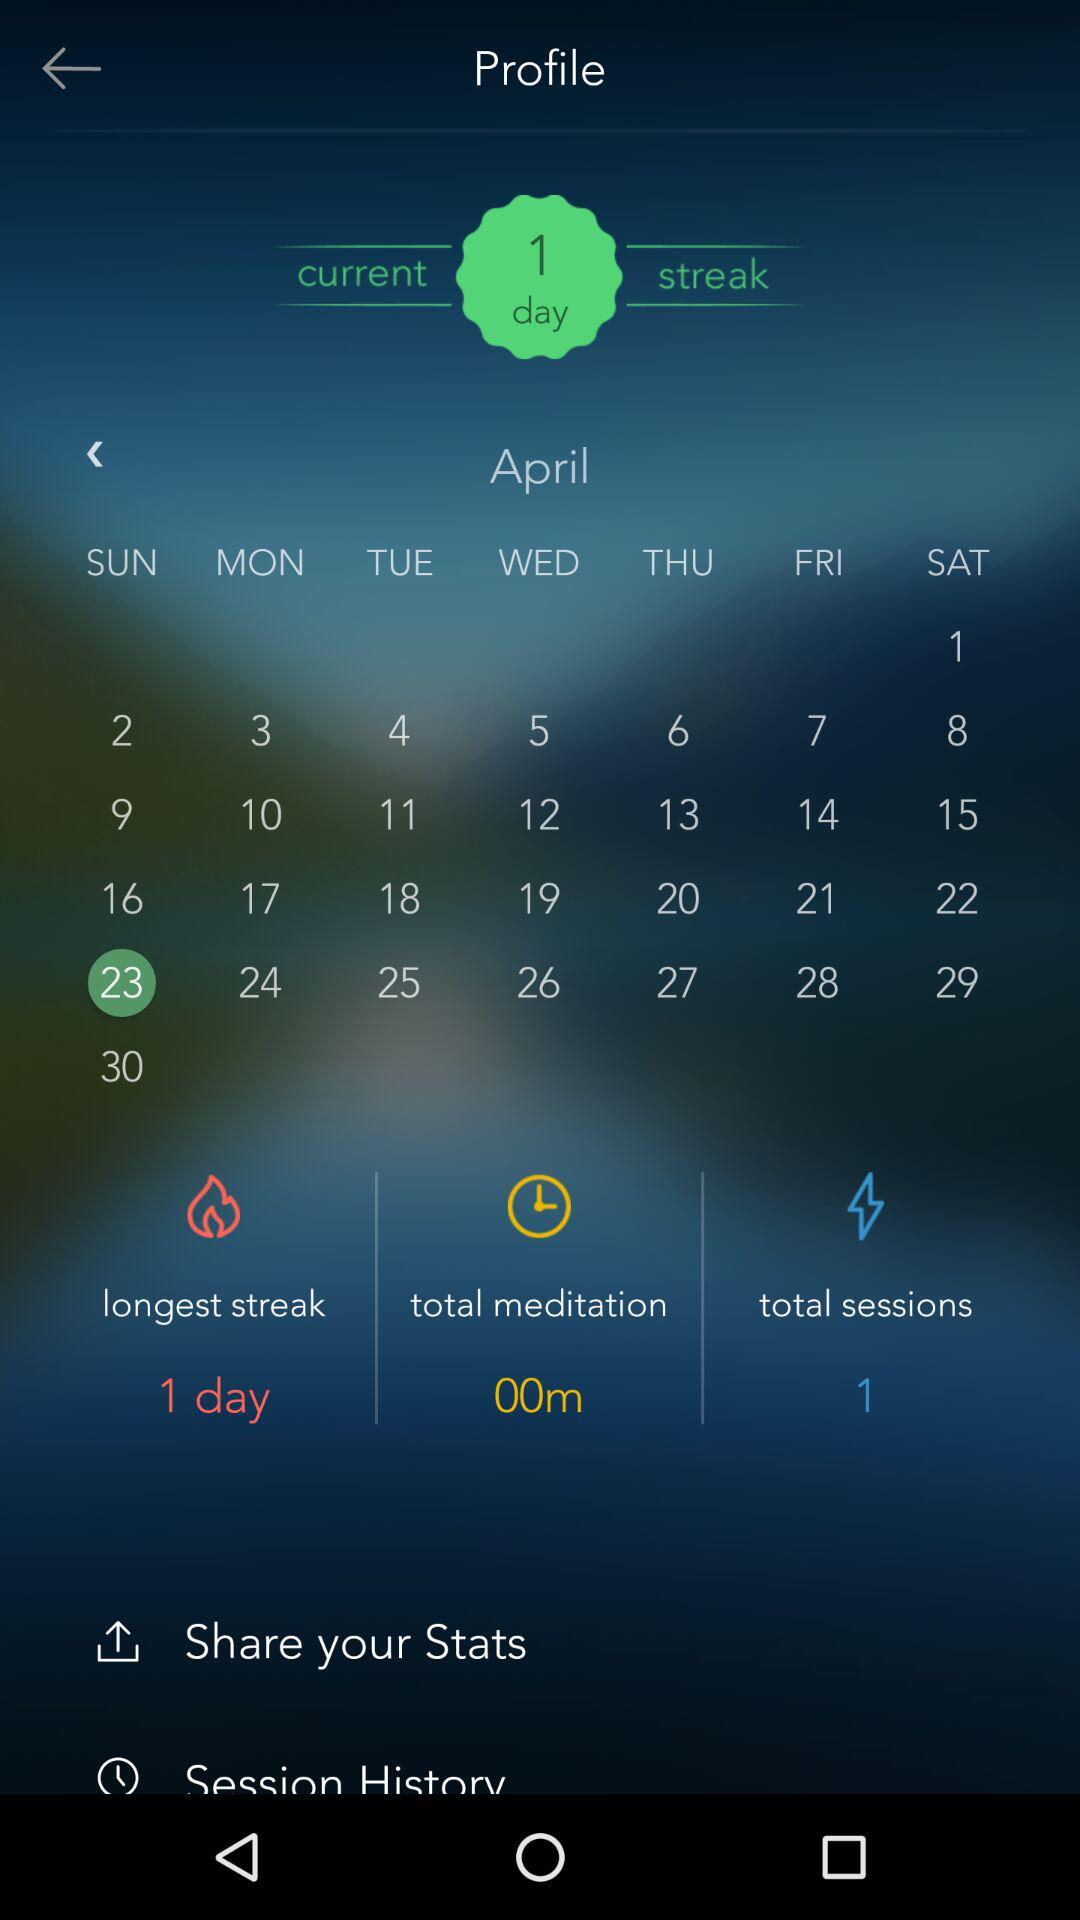How many sessions have I meditated in April?
Answer the question using a single word or phrase. 1 